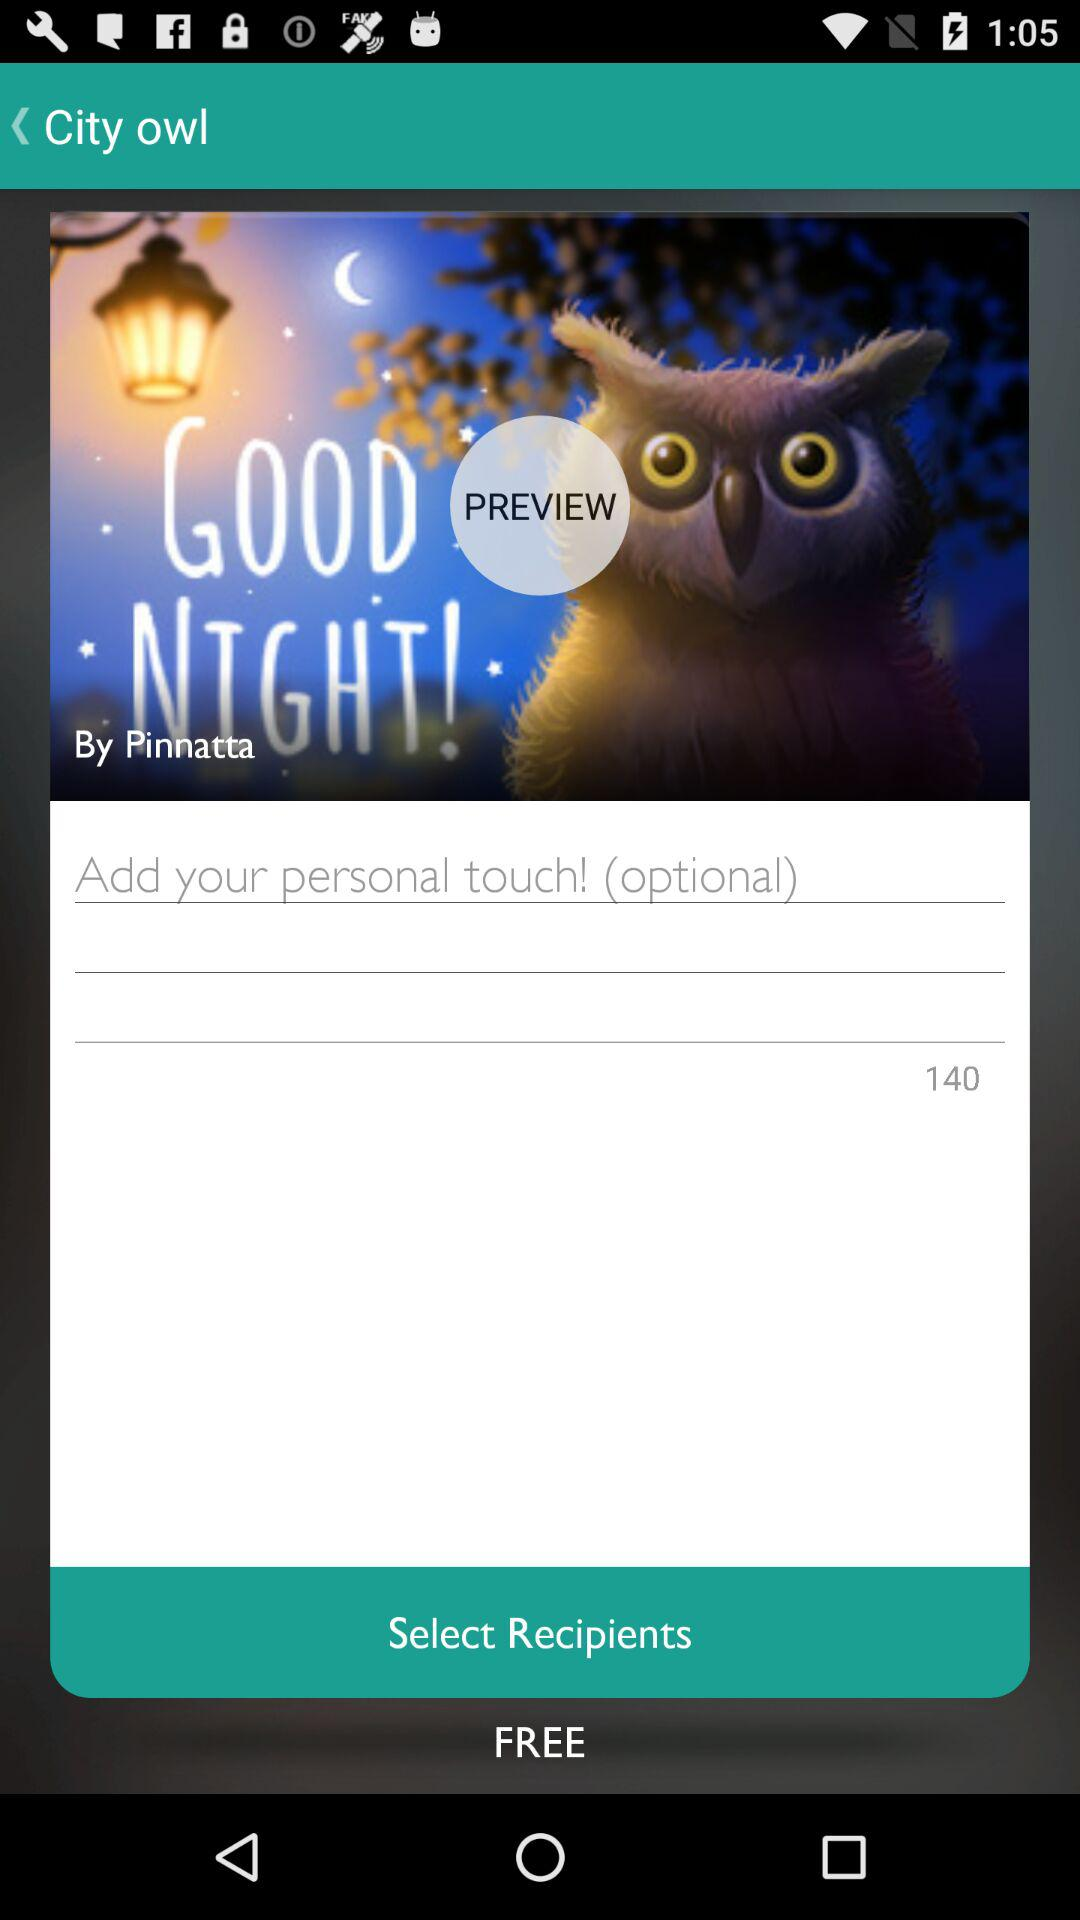What's the maximum number of alphabets that can be used? The maximum number of alphabets that can be used is 140. 